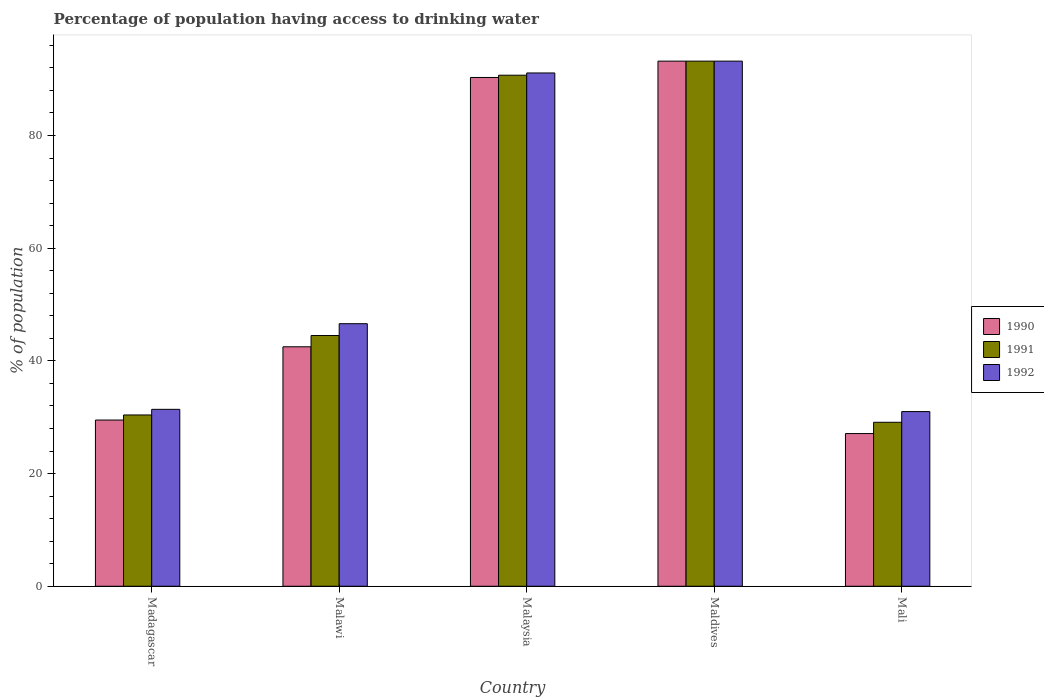How many different coloured bars are there?
Keep it short and to the point. 3. How many bars are there on the 2nd tick from the left?
Your response must be concise. 3. How many bars are there on the 5th tick from the right?
Your answer should be very brief. 3. What is the label of the 5th group of bars from the left?
Offer a very short reply. Mali. What is the percentage of population having access to drinking water in 1990 in Malaysia?
Provide a succinct answer. 90.3. Across all countries, what is the maximum percentage of population having access to drinking water in 1992?
Your answer should be very brief. 93.2. Across all countries, what is the minimum percentage of population having access to drinking water in 1990?
Your response must be concise. 27.1. In which country was the percentage of population having access to drinking water in 1990 maximum?
Your response must be concise. Maldives. In which country was the percentage of population having access to drinking water in 1990 minimum?
Keep it short and to the point. Mali. What is the total percentage of population having access to drinking water in 1992 in the graph?
Make the answer very short. 293.3. What is the difference between the percentage of population having access to drinking water in 1990 in Malawi and that in Malaysia?
Provide a succinct answer. -47.8. What is the difference between the percentage of population having access to drinking water in 1991 in Mali and the percentage of population having access to drinking water in 1992 in Malawi?
Make the answer very short. -17.5. What is the average percentage of population having access to drinking water in 1991 per country?
Provide a succinct answer. 57.58. In how many countries, is the percentage of population having access to drinking water in 1991 greater than 80 %?
Provide a short and direct response. 2. What is the ratio of the percentage of population having access to drinking water in 1992 in Malaysia to that in Maldives?
Keep it short and to the point. 0.98. What is the difference between the highest and the second highest percentage of population having access to drinking water in 1990?
Your answer should be very brief. 47.8. What is the difference between the highest and the lowest percentage of population having access to drinking water in 1992?
Your answer should be very brief. 62.2. Is the sum of the percentage of population having access to drinking water in 1991 in Madagascar and Maldives greater than the maximum percentage of population having access to drinking water in 1992 across all countries?
Your answer should be very brief. Yes. What does the 2nd bar from the left in Maldives represents?
Ensure brevity in your answer.  1991. How many bars are there?
Give a very brief answer. 15. Are all the bars in the graph horizontal?
Your answer should be very brief. No. How many countries are there in the graph?
Offer a terse response. 5. What is the difference between two consecutive major ticks on the Y-axis?
Provide a succinct answer. 20. Are the values on the major ticks of Y-axis written in scientific E-notation?
Give a very brief answer. No. Does the graph contain grids?
Keep it short and to the point. No. How many legend labels are there?
Your answer should be very brief. 3. How are the legend labels stacked?
Your answer should be compact. Vertical. What is the title of the graph?
Provide a short and direct response. Percentage of population having access to drinking water. What is the label or title of the X-axis?
Keep it short and to the point. Country. What is the label or title of the Y-axis?
Make the answer very short. % of population. What is the % of population in 1990 in Madagascar?
Keep it short and to the point. 29.5. What is the % of population in 1991 in Madagascar?
Your response must be concise. 30.4. What is the % of population in 1992 in Madagascar?
Provide a short and direct response. 31.4. What is the % of population of 1990 in Malawi?
Provide a short and direct response. 42.5. What is the % of population in 1991 in Malawi?
Offer a terse response. 44.5. What is the % of population of 1992 in Malawi?
Your answer should be very brief. 46.6. What is the % of population of 1990 in Malaysia?
Provide a short and direct response. 90.3. What is the % of population of 1991 in Malaysia?
Provide a succinct answer. 90.7. What is the % of population of 1992 in Malaysia?
Your answer should be compact. 91.1. What is the % of population in 1990 in Maldives?
Your answer should be compact. 93.2. What is the % of population of 1991 in Maldives?
Keep it short and to the point. 93.2. What is the % of population of 1992 in Maldives?
Offer a very short reply. 93.2. What is the % of population of 1990 in Mali?
Keep it short and to the point. 27.1. What is the % of population in 1991 in Mali?
Provide a short and direct response. 29.1. What is the % of population of 1992 in Mali?
Ensure brevity in your answer.  31. Across all countries, what is the maximum % of population of 1990?
Ensure brevity in your answer.  93.2. Across all countries, what is the maximum % of population of 1991?
Your answer should be very brief. 93.2. Across all countries, what is the maximum % of population of 1992?
Your answer should be compact. 93.2. Across all countries, what is the minimum % of population in 1990?
Your answer should be very brief. 27.1. Across all countries, what is the minimum % of population in 1991?
Ensure brevity in your answer.  29.1. What is the total % of population in 1990 in the graph?
Your answer should be compact. 282.6. What is the total % of population of 1991 in the graph?
Your answer should be very brief. 287.9. What is the total % of population of 1992 in the graph?
Provide a succinct answer. 293.3. What is the difference between the % of population of 1990 in Madagascar and that in Malawi?
Offer a terse response. -13. What is the difference between the % of population in 1991 in Madagascar and that in Malawi?
Your response must be concise. -14.1. What is the difference between the % of population of 1992 in Madagascar and that in Malawi?
Make the answer very short. -15.2. What is the difference between the % of population of 1990 in Madagascar and that in Malaysia?
Provide a succinct answer. -60.8. What is the difference between the % of population in 1991 in Madagascar and that in Malaysia?
Your answer should be very brief. -60.3. What is the difference between the % of population in 1992 in Madagascar and that in Malaysia?
Offer a very short reply. -59.7. What is the difference between the % of population of 1990 in Madagascar and that in Maldives?
Your response must be concise. -63.7. What is the difference between the % of population in 1991 in Madagascar and that in Maldives?
Make the answer very short. -62.8. What is the difference between the % of population in 1992 in Madagascar and that in Maldives?
Ensure brevity in your answer.  -61.8. What is the difference between the % of population of 1990 in Madagascar and that in Mali?
Your answer should be very brief. 2.4. What is the difference between the % of population of 1991 in Madagascar and that in Mali?
Offer a terse response. 1.3. What is the difference between the % of population of 1992 in Madagascar and that in Mali?
Your answer should be very brief. 0.4. What is the difference between the % of population of 1990 in Malawi and that in Malaysia?
Keep it short and to the point. -47.8. What is the difference between the % of population in 1991 in Malawi and that in Malaysia?
Offer a terse response. -46.2. What is the difference between the % of population of 1992 in Malawi and that in Malaysia?
Offer a very short reply. -44.5. What is the difference between the % of population in 1990 in Malawi and that in Maldives?
Keep it short and to the point. -50.7. What is the difference between the % of population in 1991 in Malawi and that in Maldives?
Your answer should be compact. -48.7. What is the difference between the % of population of 1992 in Malawi and that in Maldives?
Your answer should be compact. -46.6. What is the difference between the % of population in 1990 in Malawi and that in Mali?
Your response must be concise. 15.4. What is the difference between the % of population in 1991 in Malawi and that in Mali?
Keep it short and to the point. 15.4. What is the difference between the % of population of 1992 in Malawi and that in Mali?
Keep it short and to the point. 15.6. What is the difference between the % of population in 1990 in Malaysia and that in Maldives?
Your response must be concise. -2.9. What is the difference between the % of population of 1991 in Malaysia and that in Maldives?
Ensure brevity in your answer.  -2.5. What is the difference between the % of population in 1992 in Malaysia and that in Maldives?
Ensure brevity in your answer.  -2.1. What is the difference between the % of population in 1990 in Malaysia and that in Mali?
Give a very brief answer. 63.2. What is the difference between the % of population in 1991 in Malaysia and that in Mali?
Provide a short and direct response. 61.6. What is the difference between the % of population of 1992 in Malaysia and that in Mali?
Your answer should be compact. 60.1. What is the difference between the % of population in 1990 in Maldives and that in Mali?
Offer a very short reply. 66.1. What is the difference between the % of population in 1991 in Maldives and that in Mali?
Your answer should be compact. 64.1. What is the difference between the % of population of 1992 in Maldives and that in Mali?
Offer a very short reply. 62.2. What is the difference between the % of population in 1990 in Madagascar and the % of population in 1992 in Malawi?
Your answer should be very brief. -17.1. What is the difference between the % of population in 1991 in Madagascar and the % of population in 1992 in Malawi?
Make the answer very short. -16.2. What is the difference between the % of population of 1990 in Madagascar and the % of population of 1991 in Malaysia?
Provide a succinct answer. -61.2. What is the difference between the % of population in 1990 in Madagascar and the % of population in 1992 in Malaysia?
Keep it short and to the point. -61.6. What is the difference between the % of population in 1991 in Madagascar and the % of population in 1992 in Malaysia?
Ensure brevity in your answer.  -60.7. What is the difference between the % of population of 1990 in Madagascar and the % of population of 1991 in Maldives?
Offer a terse response. -63.7. What is the difference between the % of population of 1990 in Madagascar and the % of population of 1992 in Maldives?
Keep it short and to the point. -63.7. What is the difference between the % of population of 1991 in Madagascar and the % of population of 1992 in Maldives?
Ensure brevity in your answer.  -62.8. What is the difference between the % of population in 1990 in Madagascar and the % of population in 1991 in Mali?
Offer a very short reply. 0.4. What is the difference between the % of population of 1990 in Malawi and the % of population of 1991 in Malaysia?
Give a very brief answer. -48.2. What is the difference between the % of population in 1990 in Malawi and the % of population in 1992 in Malaysia?
Ensure brevity in your answer.  -48.6. What is the difference between the % of population in 1991 in Malawi and the % of population in 1992 in Malaysia?
Provide a short and direct response. -46.6. What is the difference between the % of population of 1990 in Malawi and the % of population of 1991 in Maldives?
Give a very brief answer. -50.7. What is the difference between the % of population in 1990 in Malawi and the % of population in 1992 in Maldives?
Give a very brief answer. -50.7. What is the difference between the % of population in 1991 in Malawi and the % of population in 1992 in Maldives?
Your answer should be compact. -48.7. What is the difference between the % of population in 1990 in Malawi and the % of population in 1992 in Mali?
Offer a very short reply. 11.5. What is the difference between the % of population of 1991 in Malaysia and the % of population of 1992 in Maldives?
Your answer should be compact. -2.5. What is the difference between the % of population of 1990 in Malaysia and the % of population of 1991 in Mali?
Give a very brief answer. 61.2. What is the difference between the % of population of 1990 in Malaysia and the % of population of 1992 in Mali?
Give a very brief answer. 59.3. What is the difference between the % of population of 1991 in Malaysia and the % of population of 1992 in Mali?
Keep it short and to the point. 59.7. What is the difference between the % of population in 1990 in Maldives and the % of population in 1991 in Mali?
Offer a terse response. 64.1. What is the difference between the % of population in 1990 in Maldives and the % of population in 1992 in Mali?
Your answer should be very brief. 62.2. What is the difference between the % of population of 1991 in Maldives and the % of population of 1992 in Mali?
Keep it short and to the point. 62.2. What is the average % of population of 1990 per country?
Make the answer very short. 56.52. What is the average % of population of 1991 per country?
Provide a short and direct response. 57.58. What is the average % of population in 1992 per country?
Offer a terse response. 58.66. What is the difference between the % of population in 1990 and % of population in 1991 in Madagascar?
Keep it short and to the point. -0.9. What is the difference between the % of population of 1990 and % of population of 1992 in Malawi?
Your answer should be very brief. -4.1. What is the difference between the % of population in 1991 and % of population in 1992 in Malawi?
Your answer should be compact. -2.1. What is the difference between the % of population in 1990 and % of population in 1991 in Malaysia?
Offer a terse response. -0.4. What is the difference between the % of population in 1991 and % of population in 1992 in Malaysia?
Offer a terse response. -0.4. What is the difference between the % of population in 1990 and % of population in 1991 in Maldives?
Offer a very short reply. 0. What is the difference between the % of population in 1990 and % of population in 1992 in Maldives?
Give a very brief answer. 0. What is the difference between the % of population of 1990 and % of population of 1991 in Mali?
Give a very brief answer. -2. What is the difference between the % of population in 1991 and % of population in 1992 in Mali?
Give a very brief answer. -1.9. What is the ratio of the % of population of 1990 in Madagascar to that in Malawi?
Your response must be concise. 0.69. What is the ratio of the % of population in 1991 in Madagascar to that in Malawi?
Your response must be concise. 0.68. What is the ratio of the % of population of 1992 in Madagascar to that in Malawi?
Make the answer very short. 0.67. What is the ratio of the % of population in 1990 in Madagascar to that in Malaysia?
Provide a short and direct response. 0.33. What is the ratio of the % of population of 1991 in Madagascar to that in Malaysia?
Provide a short and direct response. 0.34. What is the ratio of the % of population of 1992 in Madagascar to that in Malaysia?
Your answer should be compact. 0.34. What is the ratio of the % of population in 1990 in Madagascar to that in Maldives?
Your answer should be very brief. 0.32. What is the ratio of the % of population of 1991 in Madagascar to that in Maldives?
Keep it short and to the point. 0.33. What is the ratio of the % of population in 1992 in Madagascar to that in Maldives?
Give a very brief answer. 0.34. What is the ratio of the % of population in 1990 in Madagascar to that in Mali?
Provide a short and direct response. 1.09. What is the ratio of the % of population in 1991 in Madagascar to that in Mali?
Provide a short and direct response. 1.04. What is the ratio of the % of population in 1992 in Madagascar to that in Mali?
Your answer should be compact. 1.01. What is the ratio of the % of population in 1990 in Malawi to that in Malaysia?
Make the answer very short. 0.47. What is the ratio of the % of population of 1991 in Malawi to that in Malaysia?
Offer a very short reply. 0.49. What is the ratio of the % of population in 1992 in Malawi to that in Malaysia?
Make the answer very short. 0.51. What is the ratio of the % of population in 1990 in Malawi to that in Maldives?
Provide a succinct answer. 0.46. What is the ratio of the % of population in 1991 in Malawi to that in Maldives?
Provide a succinct answer. 0.48. What is the ratio of the % of population of 1992 in Malawi to that in Maldives?
Your response must be concise. 0.5. What is the ratio of the % of population in 1990 in Malawi to that in Mali?
Ensure brevity in your answer.  1.57. What is the ratio of the % of population of 1991 in Malawi to that in Mali?
Provide a succinct answer. 1.53. What is the ratio of the % of population in 1992 in Malawi to that in Mali?
Make the answer very short. 1.5. What is the ratio of the % of population in 1990 in Malaysia to that in Maldives?
Offer a terse response. 0.97. What is the ratio of the % of population of 1991 in Malaysia to that in Maldives?
Your answer should be very brief. 0.97. What is the ratio of the % of population in 1992 in Malaysia to that in Maldives?
Provide a short and direct response. 0.98. What is the ratio of the % of population in 1990 in Malaysia to that in Mali?
Offer a terse response. 3.33. What is the ratio of the % of population of 1991 in Malaysia to that in Mali?
Provide a short and direct response. 3.12. What is the ratio of the % of population of 1992 in Malaysia to that in Mali?
Ensure brevity in your answer.  2.94. What is the ratio of the % of population in 1990 in Maldives to that in Mali?
Keep it short and to the point. 3.44. What is the ratio of the % of population of 1991 in Maldives to that in Mali?
Provide a succinct answer. 3.2. What is the ratio of the % of population in 1992 in Maldives to that in Mali?
Provide a succinct answer. 3.01. What is the difference between the highest and the second highest % of population in 1992?
Provide a short and direct response. 2.1. What is the difference between the highest and the lowest % of population in 1990?
Provide a succinct answer. 66.1. What is the difference between the highest and the lowest % of population in 1991?
Make the answer very short. 64.1. What is the difference between the highest and the lowest % of population in 1992?
Offer a terse response. 62.2. 